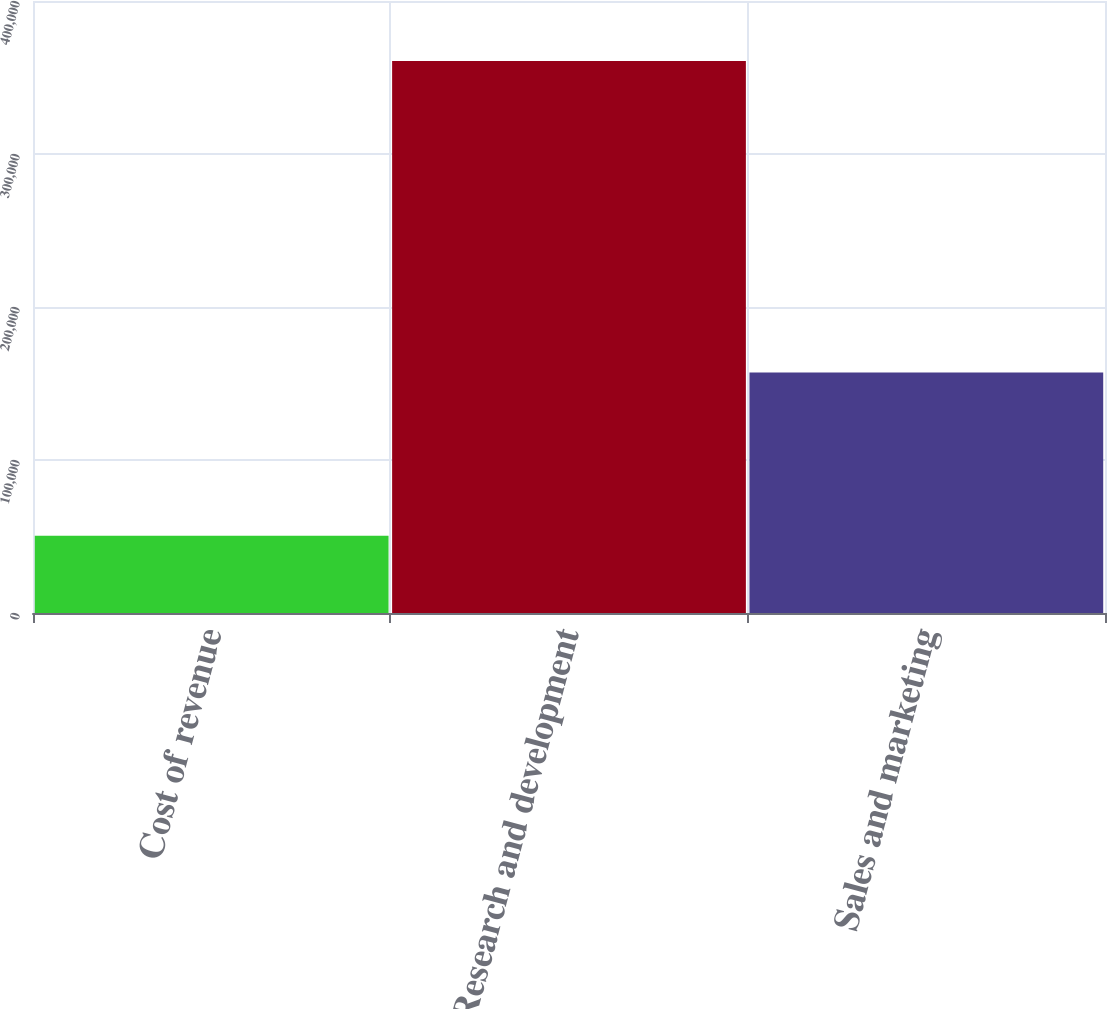Convert chart. <chart><loc_0><loc_0><loc_500><loc_500><bar_chart><fcel>Cost of revenue<fcel>Research and development<fcel>Sales and marketing<nl><fcel>50536<fcel>360726<fcel>157263<nl></chart> 